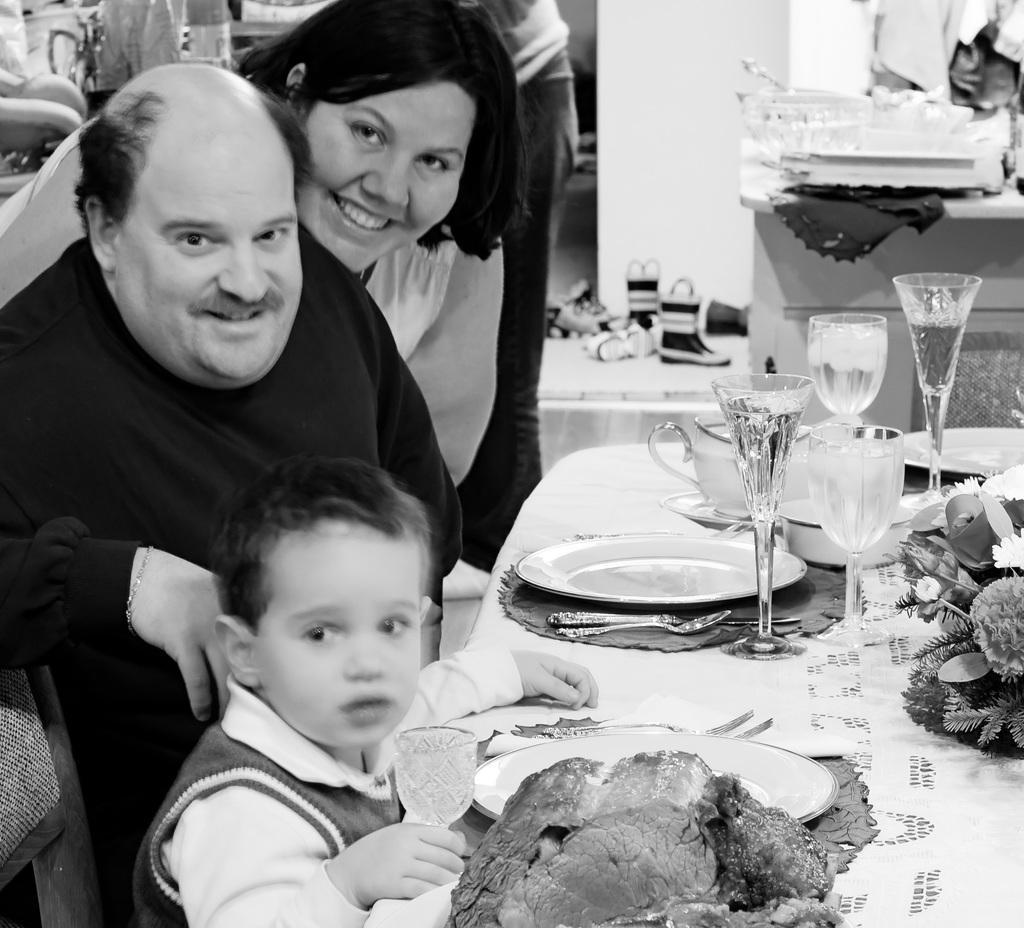In one or two sentences, can you explain what this image depicts? In this picture there is a dining table on the right side of the image, on which there are glasses, plates, and food items, there are people on the left side of the image and there is an other man behind them, there are shoes and utensils on the desks in the background area of the image. 